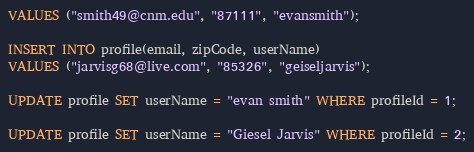<code> <loc_0><loc_0><loc_500><loc_500><_SQL_>VALUES ("smith49@cnm.edu", "87111", "evansmith");

INSERT INTO profile(email, zipCode, userName)
VALUES ("jarvisg68@live.com", "85326", "geiseljarvis");

UPDATE profile SET userName = "evan smith" WHERE profileId = 1;

UPDATE profile SET userName = "Giesel Jarvis" WHERE profileId = 2;




</code> 